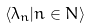<formula> <loc_0><loc_0><loc_500><loc_500>\langle \lambda _ { n } | n \in N \rangle</formula> 